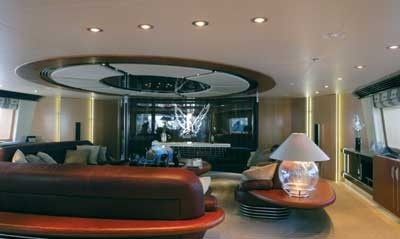Describe the objects in this image and their specific colors. I can see couch in gray, black, maroon, and brown tones, couch in gray and black tones, tv in gray, black, blue, and teal tones, vase in gray, darkgray, tan, and lightgray tones, and couch in gray, black, and maroon tones in this image. 